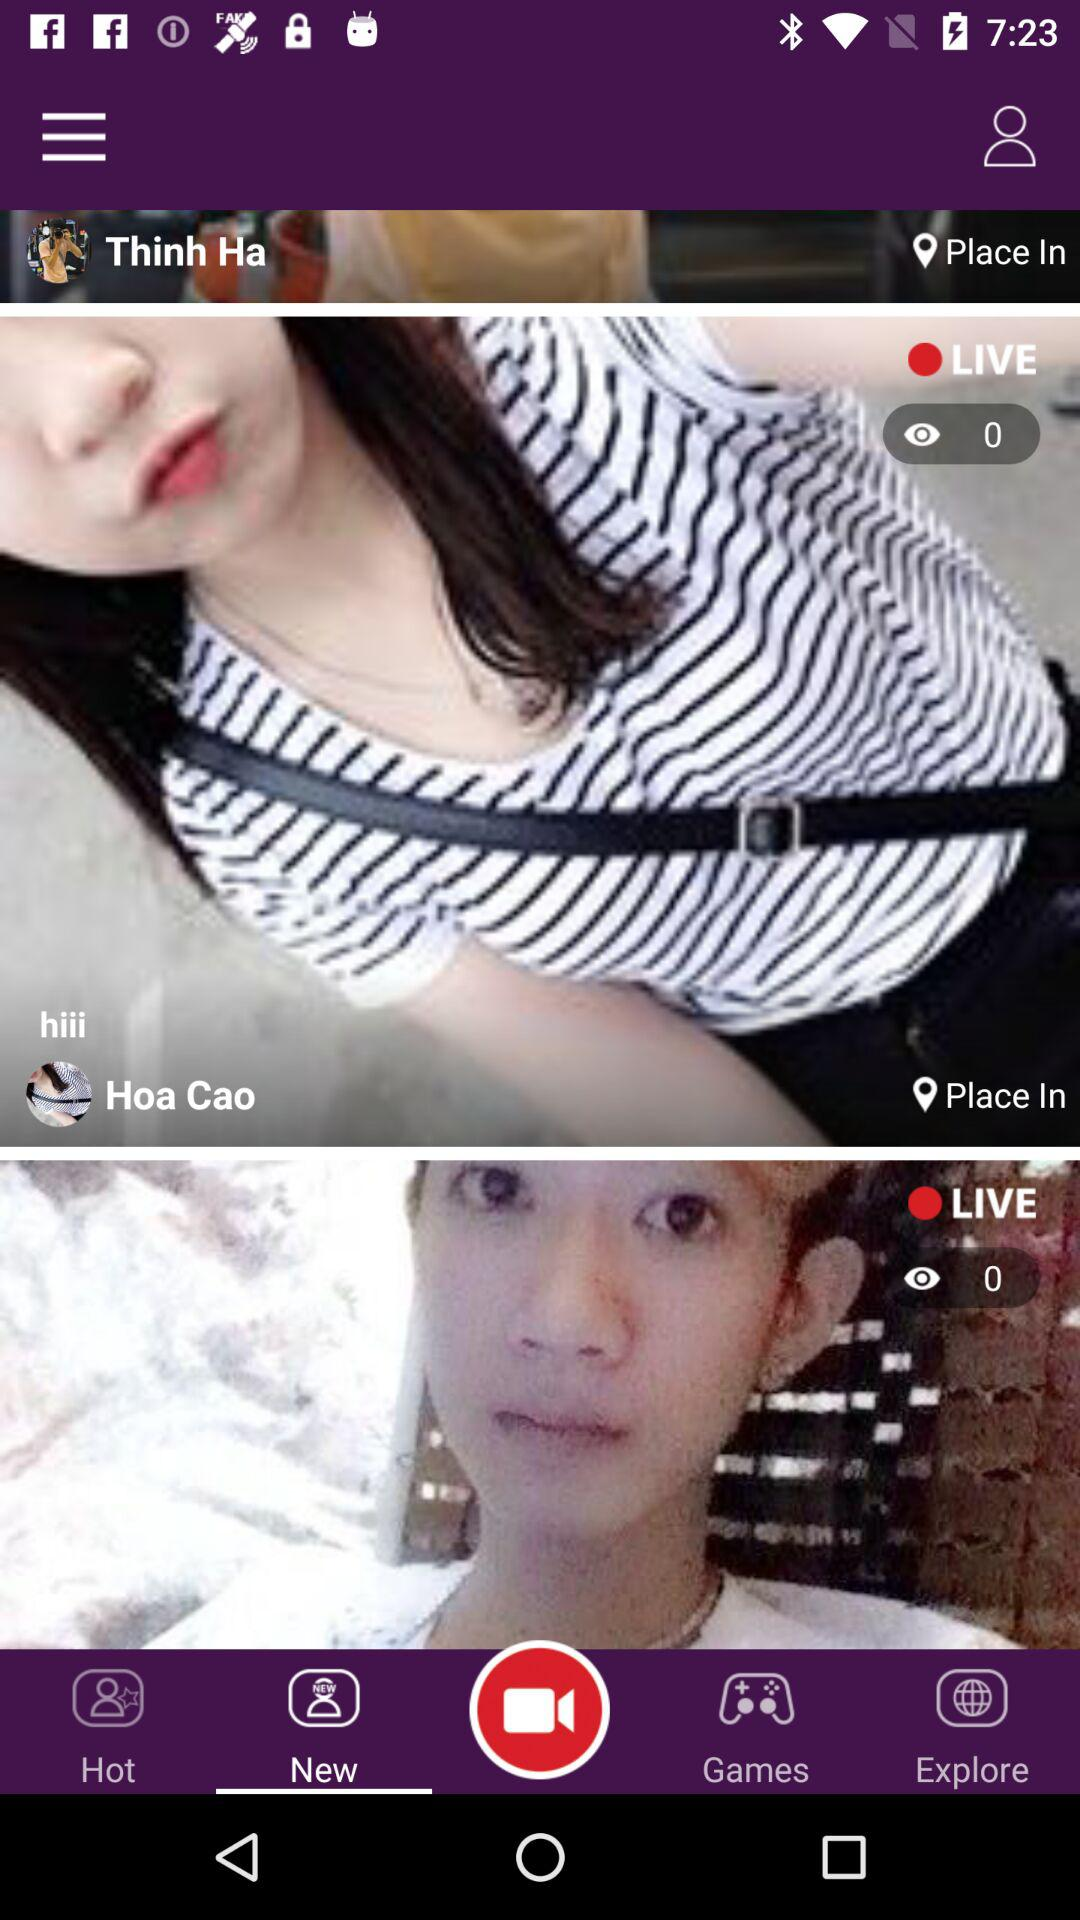What is the profile name?
When the provided information is insufficient, respond with <no answer>. <no answer> 